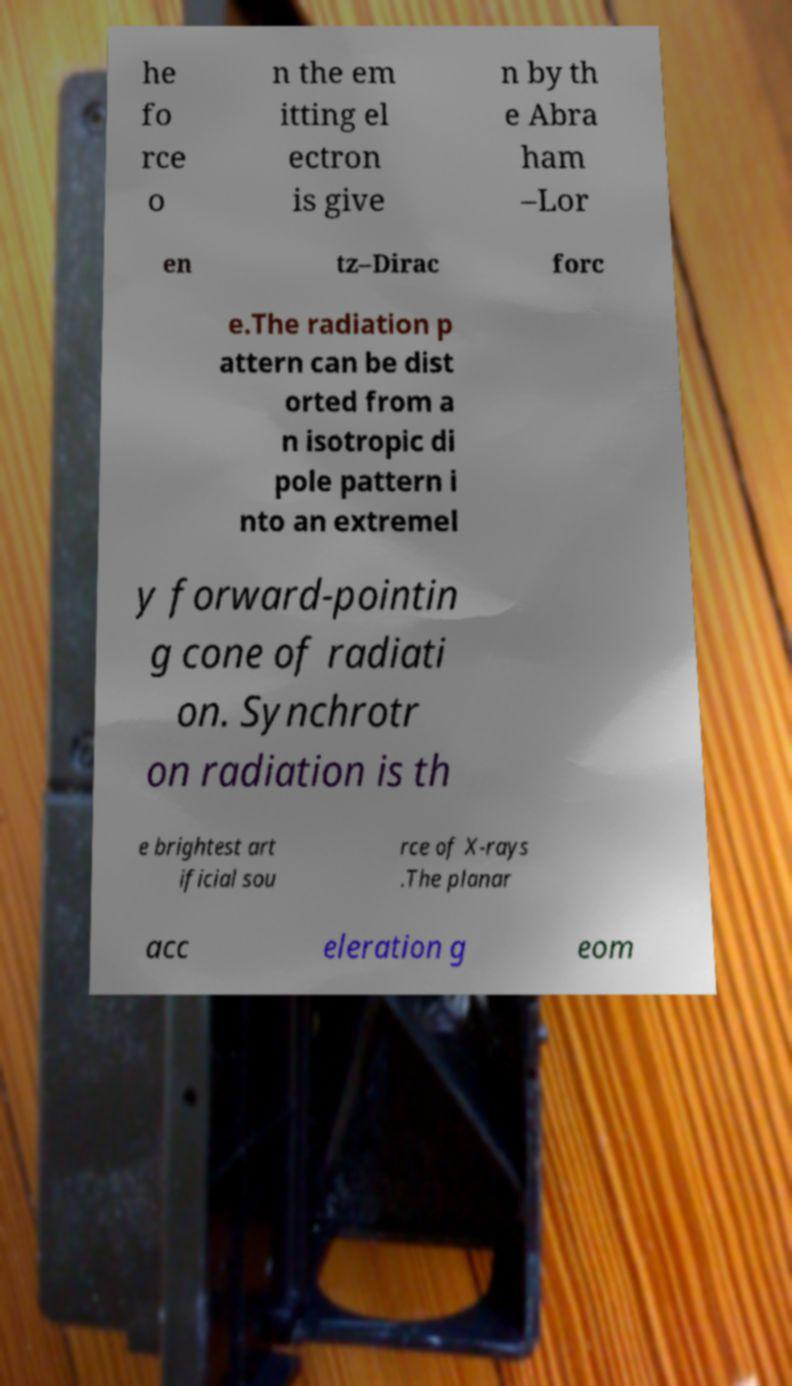What messages or text are displayed in this image? I need them in a readable, typed format. he fo rce o n the em itting el ectron is give n by th e Abra ham –Lor en tz–Dirac forc e.The radiation p attern can be dist orted from a n isotropic di pole pattern i nto an extremel y forward-pointin g cone of radiati on. Synchrotr on radiation is th e brightest art ificial sou rce of X-rays .The planar acc eleration g eom 